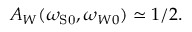<formula> <loc_0><loc_0><loc_500><loc_500>A _ { W } ( \omega _ { { S } 0 } , \omega _ { W 0 } ) \simeq 1 / 2 .</formula> 